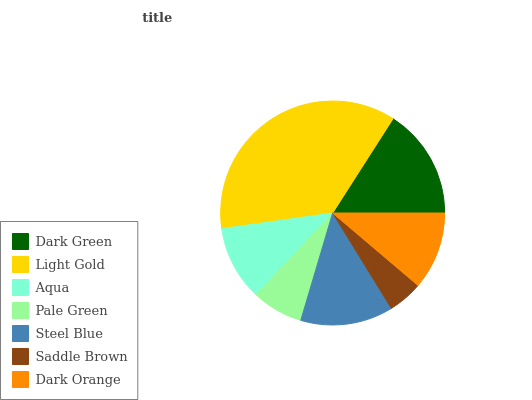Is Saddle Brown the minimum?
Answer yes or no. Yes. Is Light Gold the maximum?
Answer yes or no. Yes. Is Aqua the minimum?
Answer yes or no. No. Is Aqua the maximum?
Answer yes or no. No. Is Light Gold greater than Aqua?
Answer yes or no. Yes. Is Aqua less than Light Gold?
Answer yes or no. Yes. Is Aqua greater than Light Gold?
Answer yes or no. No. Is Light Gold less than Aqua?
Answer yes or no. No. Is Dark Orange the high median?
Answer yes or no. Yes. Is Dark Orange the low median?
Answer yes or no. Yes. Is Light Gold the high median?
Answer yes or no. No. Is Steel Blue the low median?
Answer yes or no. No. 